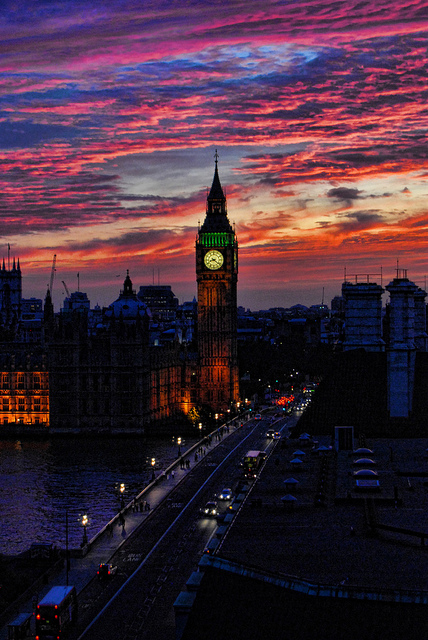<image>What time is on the clock? I am not sure what time is on the clock. What city is this? The city is ambiguous without any visual information. However, it could be London. What time is on the clock? I don't know what time is on the clock. It can be seen as 8:20. What city is this? I don't know what city this is. It can be London. 